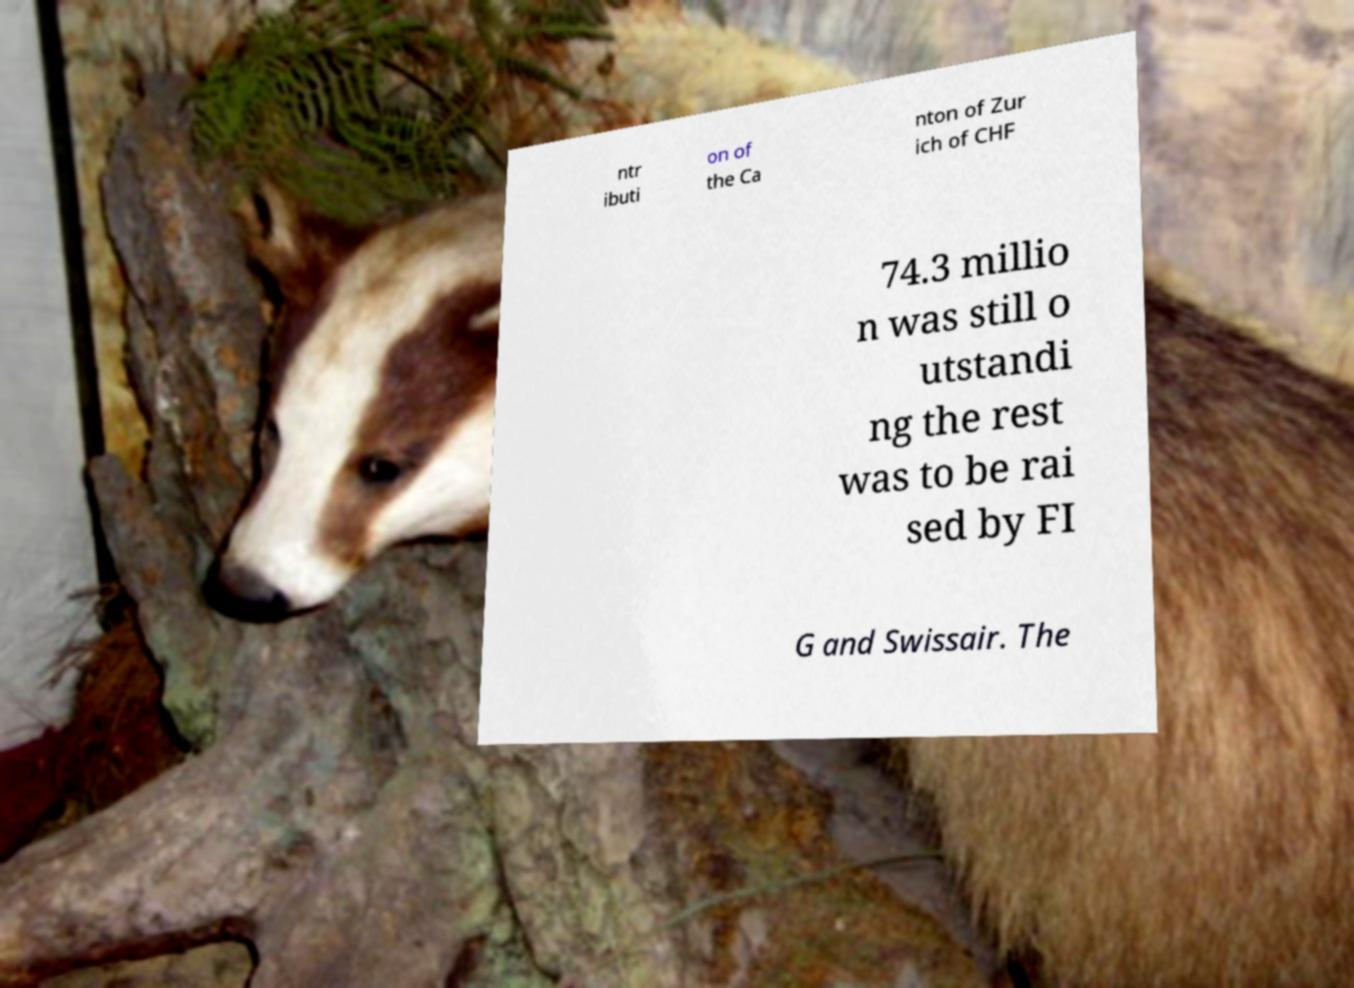What messages or text are displayed in this image? I need them in a readable, typed format. ntr ibuti on of the Ca nton of Zur ich of CHF 74.3 millio n was still o utstandi ng the rest was to be rai sed by FI G and Swissair. The 